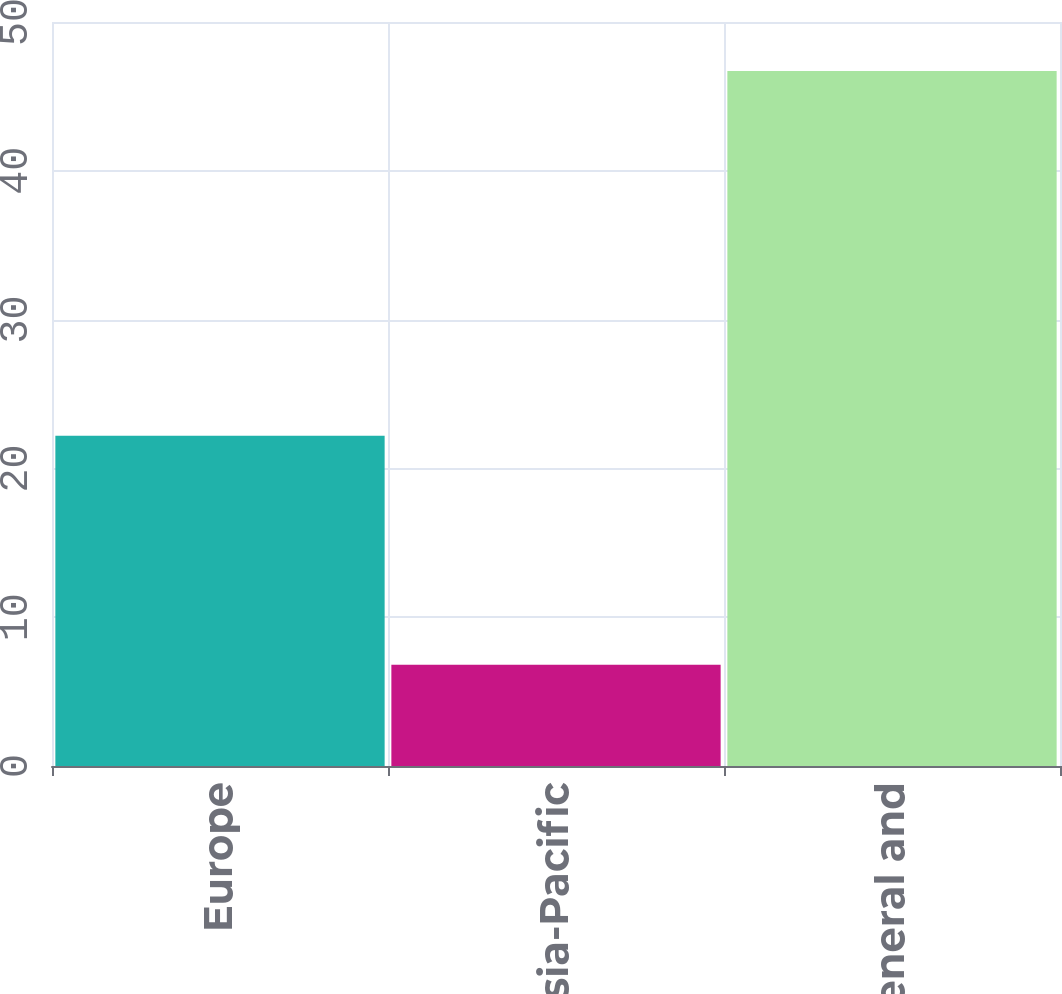Convert chart. <chart><loc_0><loc_0><loc_500><loc_500><bar_chart><fcel>Europe<fcel>Asia-Pacific<fcel>Selling general and<nl><fcel>22.2<fcel>6.8<fcel>46.7<nl></chart> 